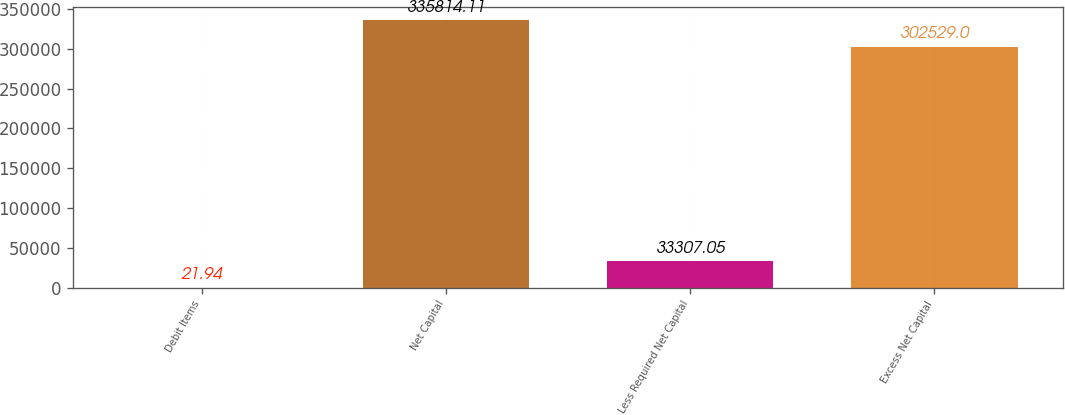Convert chart. <chart><loc_0><loc_0><loc_500><loc_500><bar_chart><fcel>Debit Items<fcel>Net Capital<fcel>Less Required Net Capital<fcel>Excess Net Capital<nl><fcel>21.94<fcel>335814<fcel>33307.1<fcel>302529<nl></chart> 